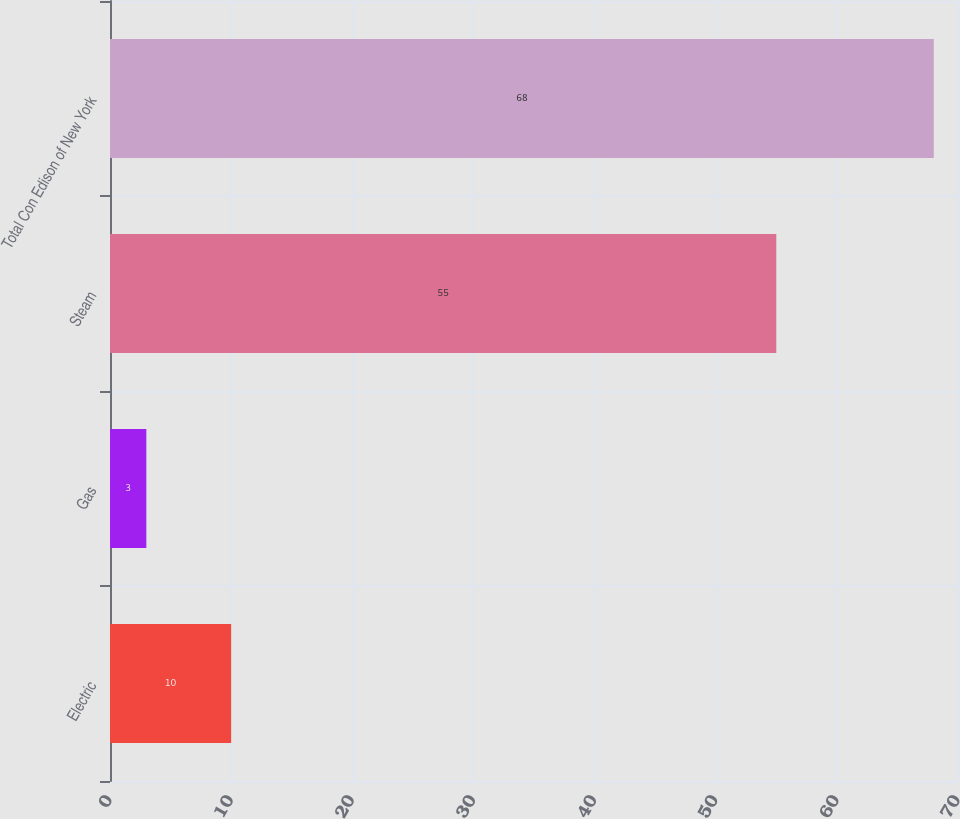Convert chart to OTSL. <chart><loc_0><loc_0><loc_500><loc_500><bar_chart><fcel>Electric<fcel>Gas<fcel>Steam<fcel>Total Con Edison of New York<nl><fcel>10<fcel>3<fcel>55<fcel>68<nl></chart> 